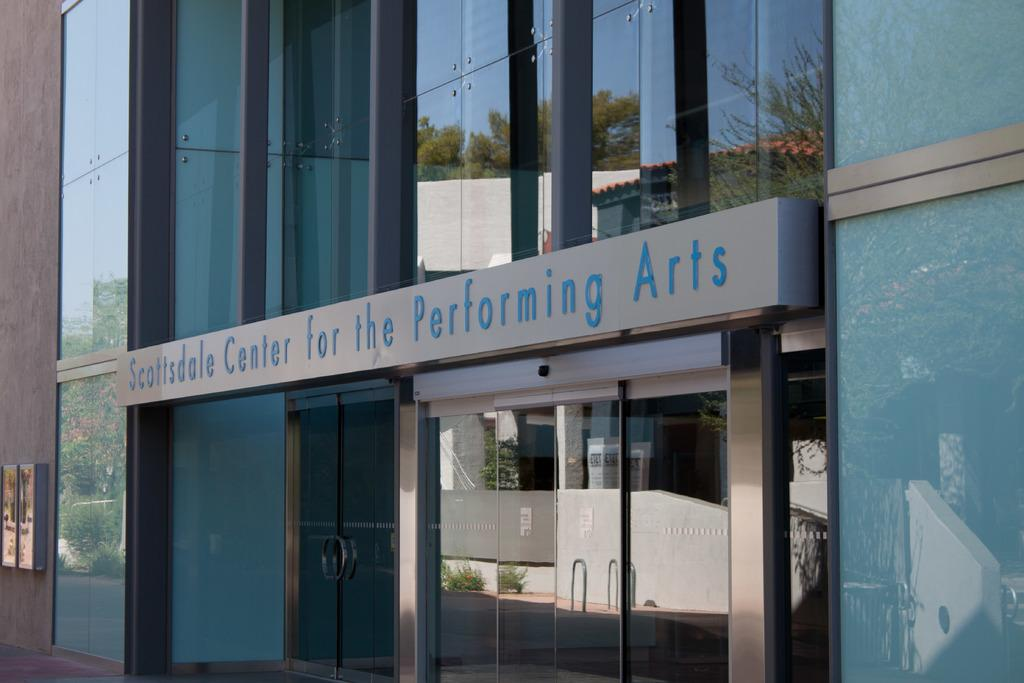What type of structure is in the picture? There is a building in the picture. What feature can be seen on the building? The building has glass windows. What else is present in the picture besides the building? There is a board in the picture. What can be observed in the reflections on the glass windows? The glass windows have reflections of the building, plants, boards, the sky, and trees. What type of pan is being used to cook food in the image? There is no pan or cooking activity present in the image. Who is the owner of the building in the image? The image does not provide information about the ownership of the building. 